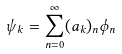Convert formula to latex. <formula><loc_0><loc_0><loc_500><loc_500>\psi _ { k } = \sum _ { n = 0 } ^ { \infty } ( a _ { k } ) _ { n } \phi _ { n }</formula> 